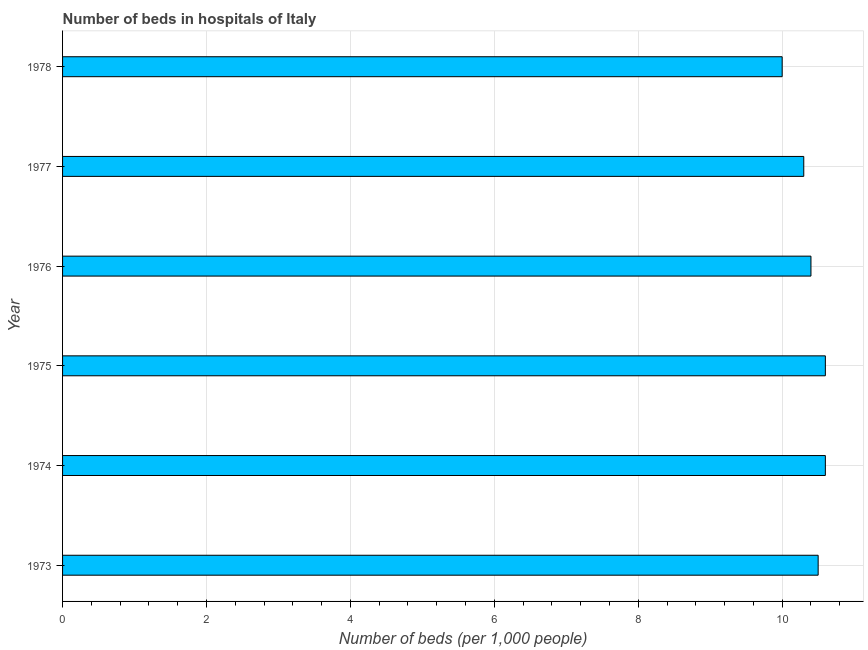What is the title of the graph?
Offer a terse response. Number of beds in hospitals of Italy. What is the label or title of the X-axis?
Ensure brevity in your answer.  Number of beds (per 1,0 people). What is the number of hospital beds in 1976?
Provide a succinct answer. 10.4. Across all years, what is the maximum number of hospital beds?
Provide a succinct answer. 10.6. In which year was the number of hospital beds maximum?
Provide a succinct answer. 1974. In which year was the number of hospital beds minimum?
Provide a short and direct response. 1978. What is the sum of the number of hospital beds?
Provide a succinct answer. 62.4. What is the difference between the number of hospital beds in 1975 and 1977?
Ensure brevity in your answer.  0.3. What is the average number of hospital beds per year?
Give a very brief answer. 10.4. What is the median number of hospital beds?
Offer a terse response. 10.45. In how many years, is the number of hospital beds greater than 9.6 %?
Ensure brevity in your answer.  6. Do a majority of the years between 1974 and 1978 (inclusive) have number of hospital beds greater than 9.2 %?
Keep it short and to the point. Yes. What is the ratio of the number of hospital beds in 1975 to that in 1976?
Your answer should be compact. 1.02. Is the number of hospital beds in 1976 less than that in 1978?
Offer a very short reply. No. What is the difference between the highest and the second highest number of hospital beds?
Your answer should be very brief. 0. What is the difference between the highest and the lowest number of hospital beds?
Your answer should be compact. 0.6. How many bars are there?
Your answer should be compact. 6. How many years are there in the graph?
Make the answer very short. 6. What is the difference between two consecutive major ticks on the X-axis?
Your answer should be very brief. 2. What is the Number of beds (per 1,000 people) of 1974?
Your answer should be very brief. 10.6. What is the Number of beds (per 1,000 people) in 1975?
Offer a very short reply. 10.6. What is the Number of beds (per 1,000 people) in 1976?
Provide a short and direct response. 10.4. What is the Number of beds (per 1,000 people) of 1977?
Offer a very short reply. 10.3. What is the difference between the Number of beds (per 1,000 people) in 1973 and 1978?
Offer a terse response. 0.5. What is the difference between the Number of beds (per 1,000 people) in 1974 and 1976?
Provide a short and direct response. 0.2. What is the difference between the Number of beds (per 1,000 people) in 1974 and 1977?
Your response must be concise. 0.3. What is the difference between the Number of beds (per 1,000 people) in 1975 and 1976?
Keep it short and to the point. 0.2. What is the difference between the Number of beds (per 1,000 people) in 1976 and 1978?
Provide a succinct answer. 0.4. What is the ratio of the Number of beds (per 1,000 people) in 1973 to that in 1974?
Your answer should be compact. 0.99. What is the ratio of the Number of beds (per 1,000 people) in 1973 to that in 1976?
Offer a very short reply. 1.01. What is the ratio of the Number of beds (per 1,000 people) in 1973 to that in 1977?
Offer a terse response. 1.02. What is the ratio of the Number of beds (per 1,000 people) in 1974 to that in 1976?
Make the answer very short. 1.02. What is the ratio of the Number of beds (per 1,000 people) in 1974 to that in 1978?
Give a very brief answer. 1.06. What is the ratio of the Number of beds (per 1,000 people) in 1975 to that in 1976?
Ensure brevity in your answer.  1.02. What is the ratio of the Number of beds (per 1,000 people) in 1975 to that in 1977?
Your answer should be compact. 1.03. What is the ratio of the Number of beds (per 1,000 people) in 1975 to that in 1978?
Provide a succinct answer. 1.06. What is the ratio of the Number of beds (per 1,000 people) in 1976 to that in 1977?
Provide a short and direct response. 1.01. 